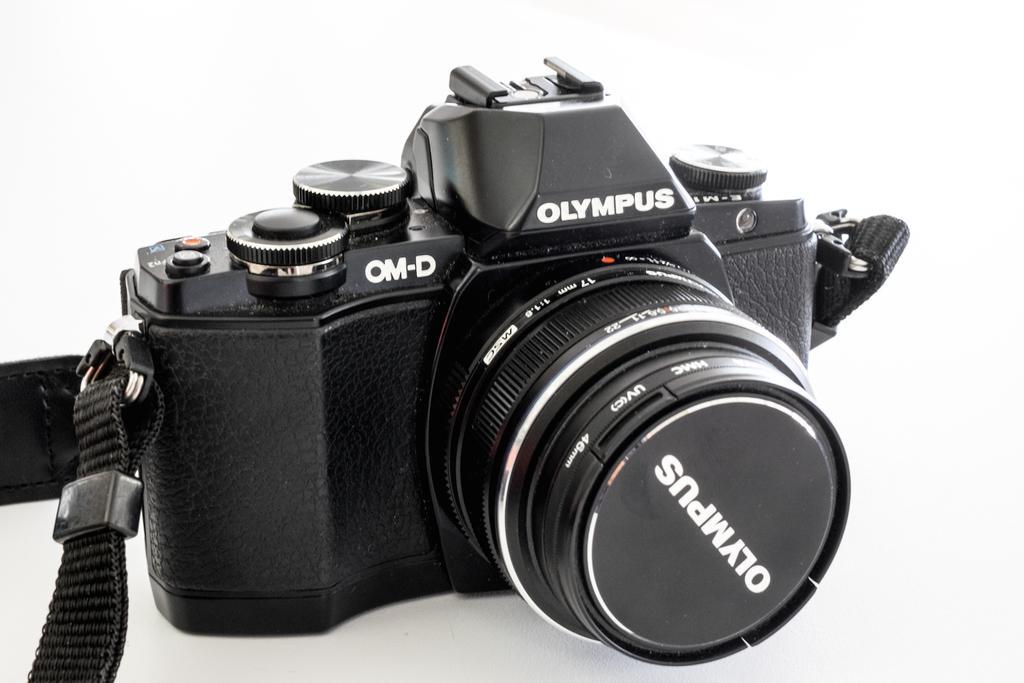Please provide a concise description of this image. This is a zoomed in picture. In the center there is a camera on which we can see the text. The background of the image is white in color. 